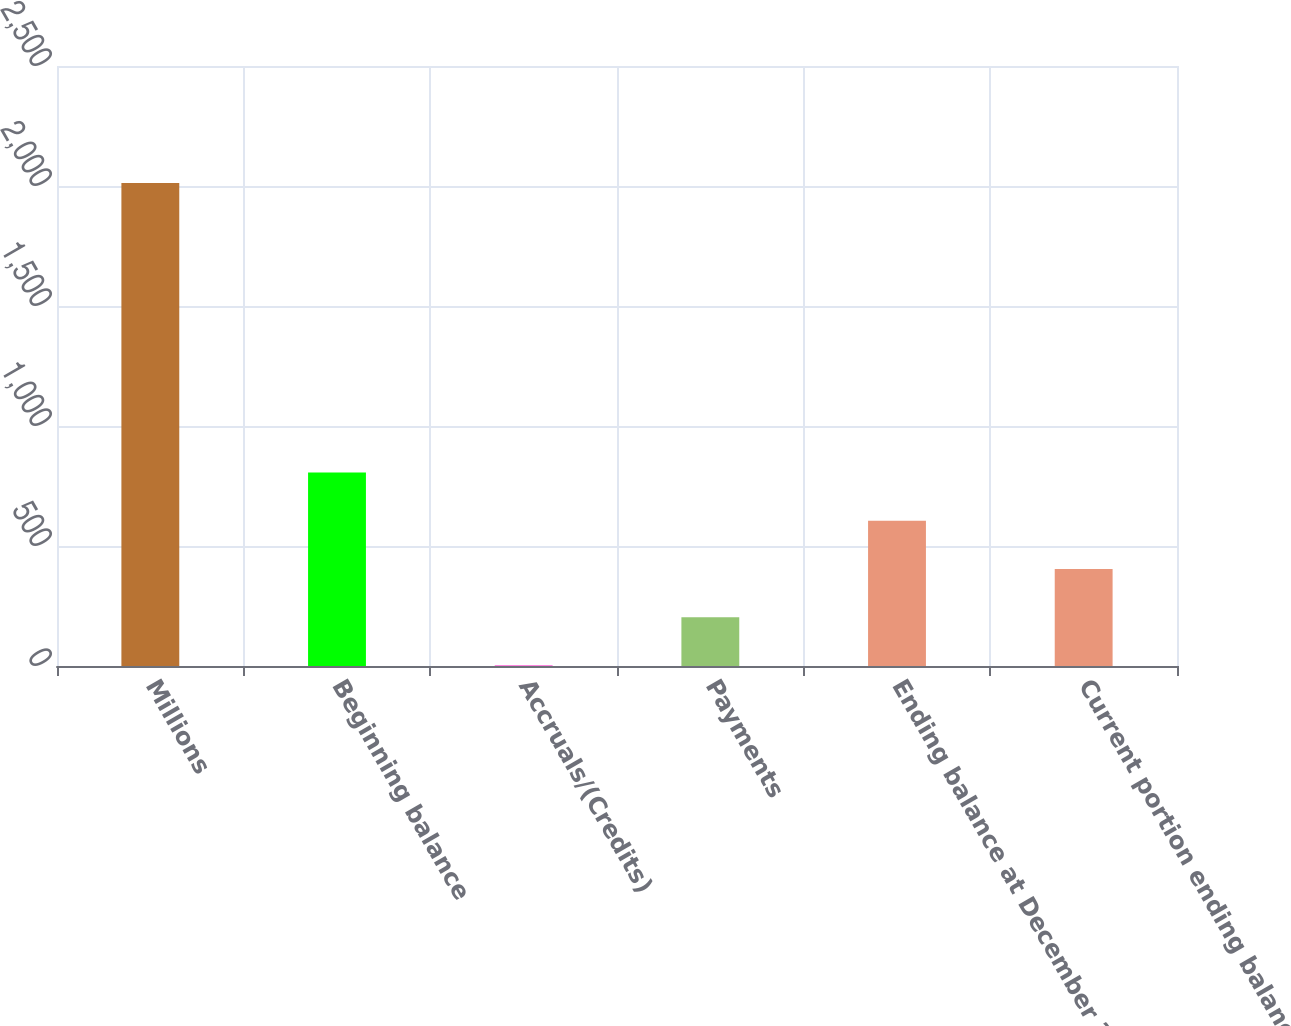<chart> <loc_0><loc_0><loc_500><loc_500><bar_chart><fcel>Millions<fcel>Beginning balance<fcel>Accruals/(Credits)<fcel>Payments<fcel>Ending balance at December 31<fcel>Current portion ending balance<nl><fcel>2012<fcel>806<fcel>2<fcel>203<fcel>605<fcel>404<nl></chart> 